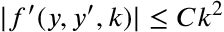Convert formula to latex. <formula><loc_0><loc_0><loc_500><loc_500>| f ^ { \prime } ( y , y ^ { \prime } , k ) | \leq C k ^ { 2 }</formula> 